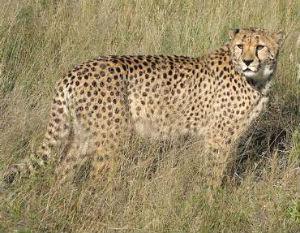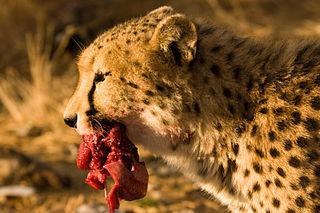The first image is the image on the left, the second image is the image on the right. Evaluate the accuracy of this statement regarding the images: "There is at least one cheetah in motion.". Is it true? Answer yes or no. No. The first image is the image on the left, the second image is the image on the right. Analyze the images presented: Is the assertion "One of the big cats is running very fast and the others are eating." valid? Answer yes or no. No. 